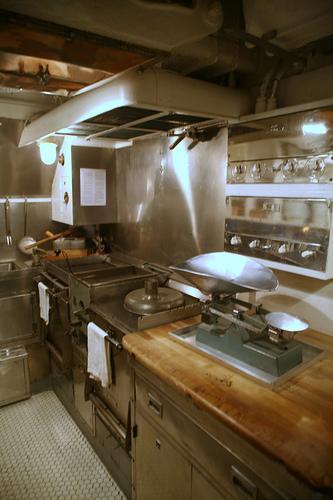How many people are wearing red?
Give a very brief answer. 0. 